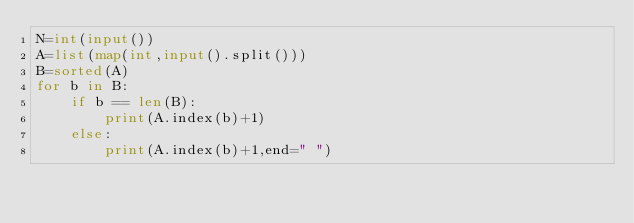<code> <loc_0><loc_0><loc_500><loc_500><_Python_>N=int(input())
A=list(map(int,input().split()))
B=sorted(A)
for b in B:
    if b == len(B):
        print(A.index(b)+1)
    else:
        print(A.index(b)+1,end=" ")
</code> 